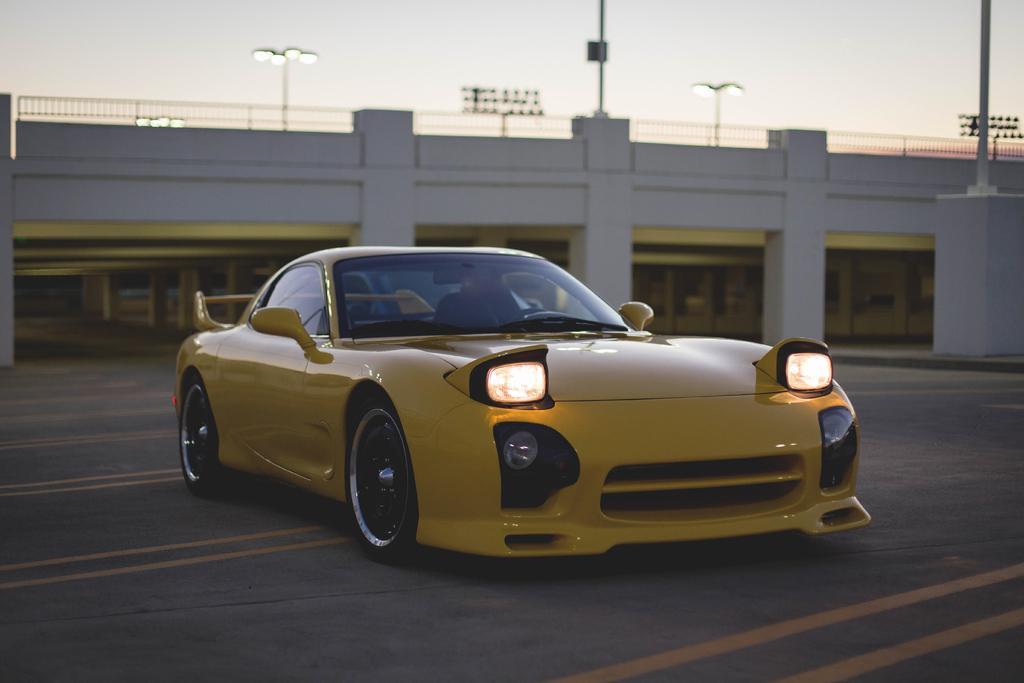In one or two sentences, can you explain what this image depicts? In this picture we can see a car on the road, pillars, fence, lights, poles and in the background we can see the sky. 